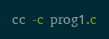Convert code to text. <code><loc_0><loc_0><loc_500><loc_500><_SQL_>cc -c prog1.c
</code> 